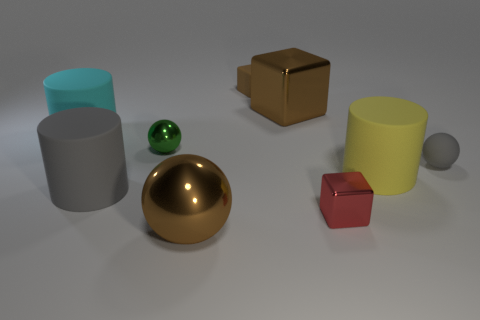What number of rubber things have the same color as the rubber ball?
Ensure brevity in your answer.  1. How many other objects are the same color as the small rubber cube?
Your answer should be compact. 2. Are there any other things that are made of the same material as the gray ball?
Offer a terse response. Yes. What number of small blue matte cylinders are there?
Your response must be concise. 0. Is the large metallic ball the same color as the small rubber sphere?
Keep it short and to the point. No. There is a small thing that is both on the left side of the red object and in front of the brown rubber block; what color is it?
Provide a short and direct response. Green. Are there any small things behind the green shiny object?
Give a very brief answer. Yes. There is a tiny object that is right of the yellow rubber thing; what number of balls are in front of it?
Offer a very short reply. 1. There is a brown cube that is the same material as the tiny red object; what size is it?
Your answer should be compact. Large. How big is the green metal object?
Provide a succinct answer. Small. 